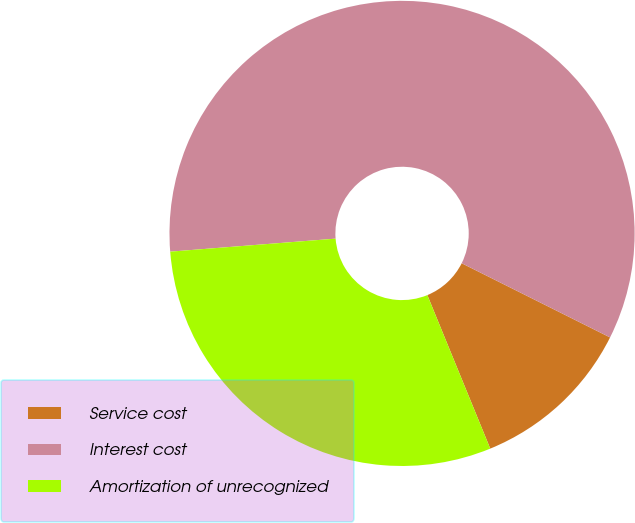Convert chart. <chart><loc_0><loc_0><loc_500><loc_500><pie_chart><fcel>Service cost<fcel>Interest cost<fcel>Amortization of unrecognized<nl><fcel>11.43%<fcel>58.63%<fcel>29.94%<nl></chart> 